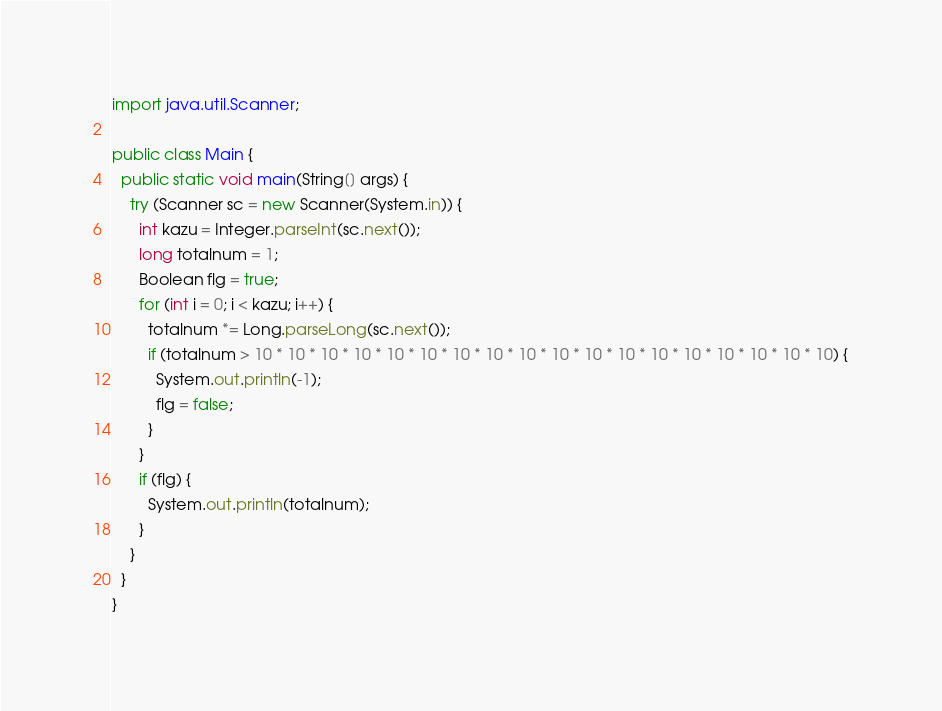<code> <loc_0><loc_0><loc_500><loc_500><_Java_>import java.util.Scanner;

public class Main {
  public static void main(String[] args) {
    try (Scanner sc = new Scanner(System.in)) {
      int kazu = Integer.parseInt(sc.next());
      long totalnum = 1;
      Boolean flg = true;
      for (int i = 0; i < kazu; i++) {
        totalnum *= Long.parseLong(sc.next());
        if (totalnum > 10 * 10 * 10 * 10 * 10 * 10 * 10 * 10 * 10 * 10 * 10 * 10 * 10 * 10 * 10 * 10 * 10 * 10) {
          System.out.println(-1);
          flg = false;
        }
      }
      if (flg) {
        System.out.println(totalnum);
      }
    }
  }
}</code> 